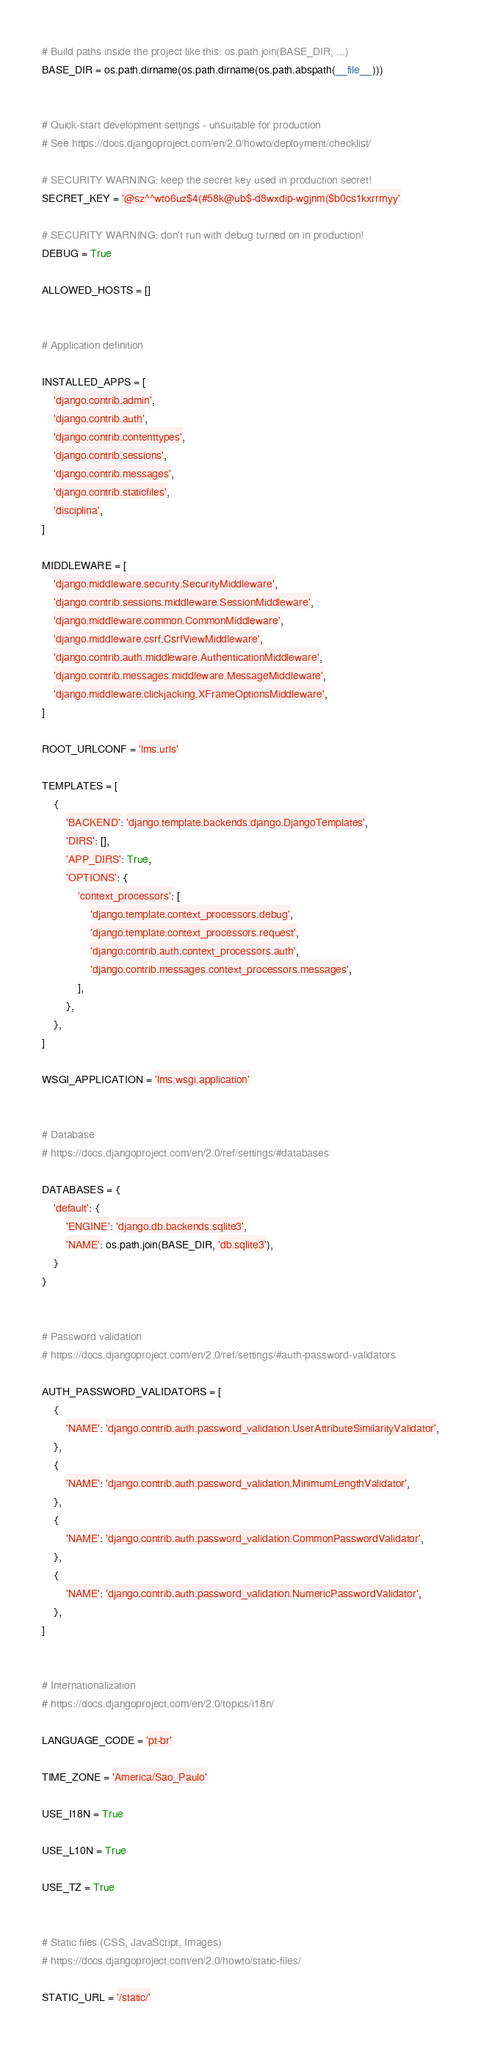Convert code to text. <code><loc_0><loc_0><loc_500><loc_500><_Python_># Build paths inside the project like this: os.path.join(BASE_DIR, ...)
BASE_DIR = os.path.dirname(os.path.dirname(os.path.abspath(__file__)))


# Quick-start development settings - unsuitable for production
# See https://docs.djangoproject.com/en/2.0/howto/deployment/checklist/

# SECURITY WARNING: keep the secret key used in production secret!
SECRET_KEY = '@sz^^wto6uz$4(#58k@ub$-d8wxdip-wgjnm($b0cs1kxrrmyy'

# SECURITY WARNING: don't run with debug turned on in production!
DEBUG = True

ALLOWED_HOSTS = []


# Application definition

INSTALLED_APPS = [
    'django.contrib.admin',
    'django.contrib.auth',
    'django.contrib.contenttypes',
    'django.contrib.sessions',
    'django.contrib.messages',
    'django.contrib.staticfiles',
    'disciplina',
]

MIDDLEWARE = [
    'django.middleware.security.SecurityMiddleware',
    'django.contrib.sessions.middleware.SessionMiddleware',
    'django.middleware.common.CommonMiddleware',
    'django.middleware.csrf.CsrfViewMiddleware',
    'django.contrib.auth.middleware.AuthenticationMiddleware',
    'django.contrib.messages.middleware.MessageMiddleware',
    'django.middleware.clickjacking.XFrameOptionsMiddleware',
]

ROOT_URLCONF = 'lms.urls'

TEMPLATES = [
    {
        'BACKEND': 'django.template.backends.django.DjangoTemplates',
        'DIRS': [],
        'APP_DIRS': True,
        'OPTIONS': {
            'context_processors': [
                'django.template.context_processors.debug',
                'django.template.context_processors.request',
                'django.contrib.auth.context_processors.auth',
                'django.contrib.messages.context_processors.messages',
            ],
        },
    },
]

WSGI_APPLICATION = 'lms.wsgi.application'


# Database
# https://docs.djangoproject.com/en/2.0/ref/settings/#databases

DATABASES = {
    'default': {
        'ENGINE': 'django.db.backends.sqlite3',
        'NAME': os.path.join(BASE_DIR, 'db.sqlite3'),
    }
}


# Password validation
# https://docs.djangoproject.com/en/2.0/ref/settings/#auth-password-validators

AUTH_PASSWORD_VALIDATORS = [
    {
        'NAME': 'django.contrib.auth.password_validation.UserAttributeSimilarityValidator',
    },
    {
        'NAME': 'django.contrib.auth.password_validation.MinimumLengthValidator',
    },
    {
        'NAME': 'django.contrib.auth.password_validation.CommonPasswordValidator',
    },
    {
        'NAME': 'django.contrib.auth.password_validation.NumericPasswordValidator',
    },
]


# Internationalization
# https://docs.djangoproject.com/en/2.0/topics/i18n/

LANGUAGE_CODE = 'pt-br'

TIME_ZONE = 'America/Sao_Paulo'

USE_I18N = True

USE_L10N = True

USE_TZ = True


# Static files (CSS, JavaScript, Images)
# https://docs.djangoproject.com/en/2.0/howto/static-files/

STATIC_URL = '/static/'
</code> 